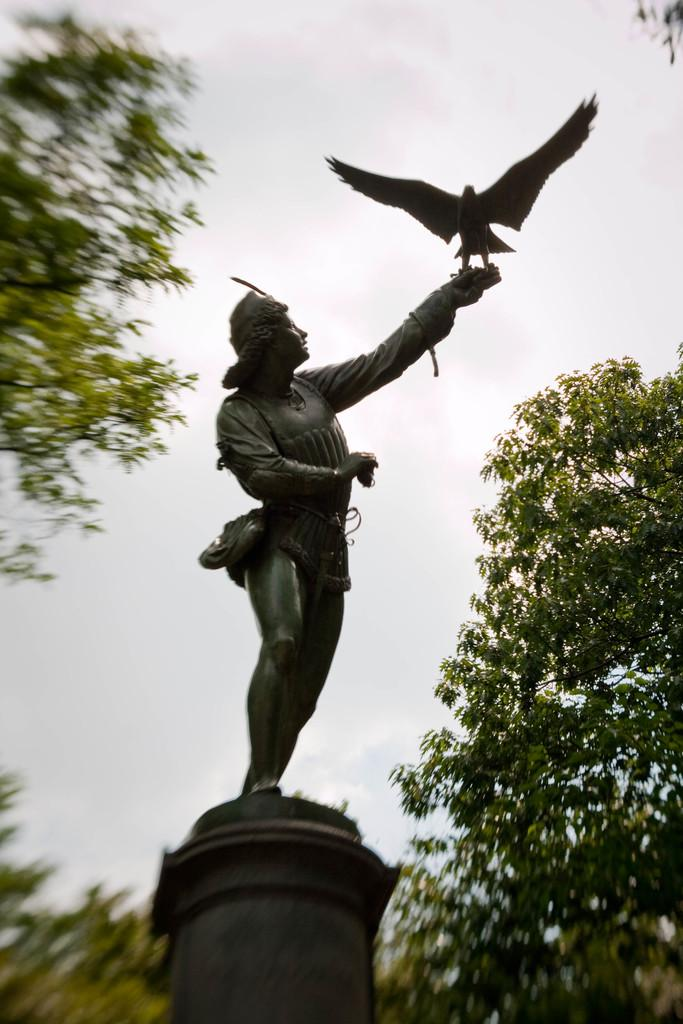What is the main subject of the image? There is a statue of a person in the image. What is the statue holding? The statue is holding a bird. What can be seen in the background of the image? There are trees visible in the background of the image. What is visible at the top of the image? The sky is visible at the top of the image. What type of gold jewelry is the statue wearing in the image? There is no gold jewelry visible on the statue in the image. 